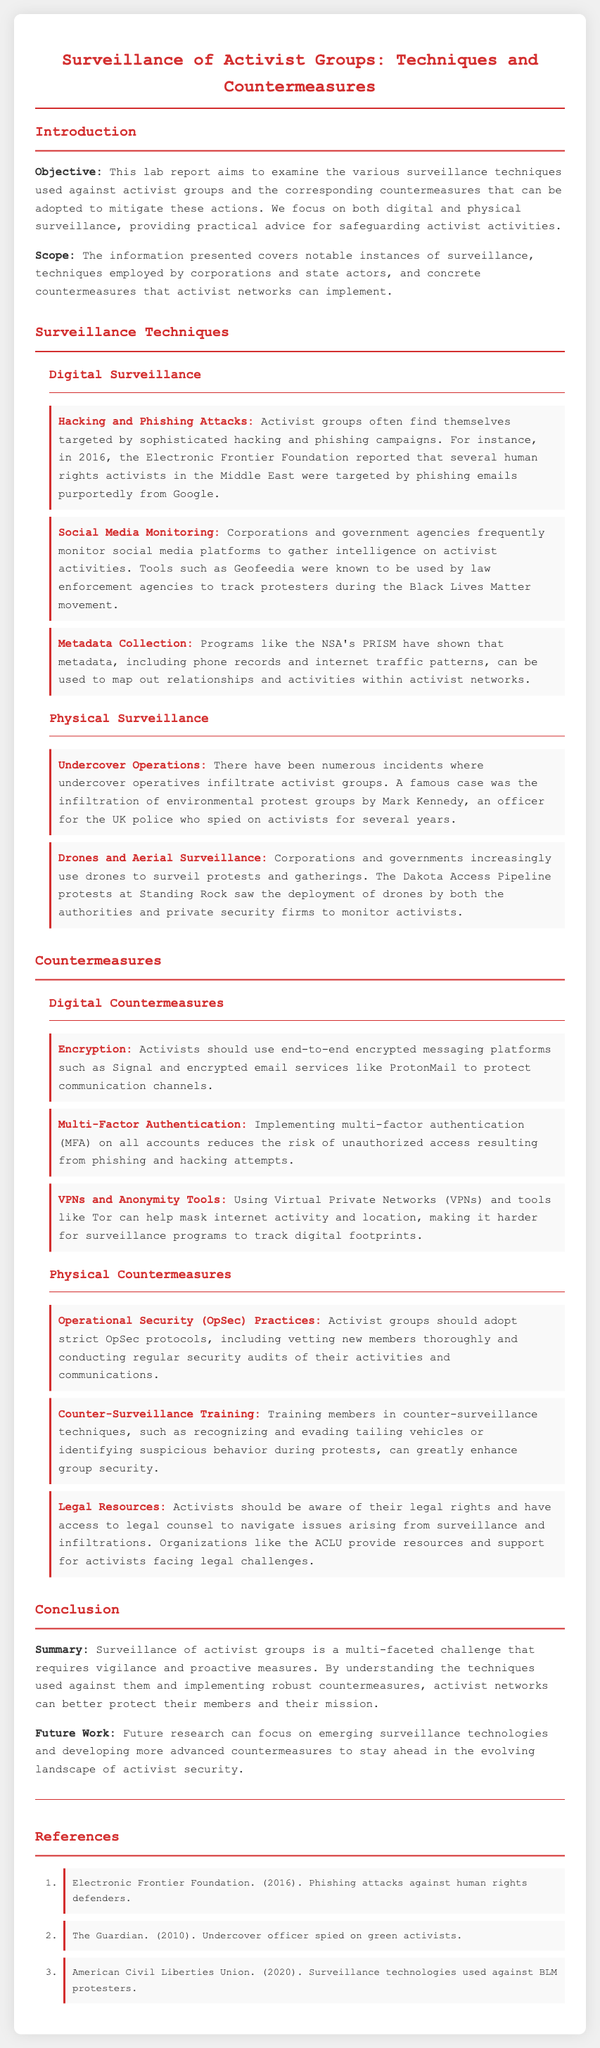what is the objective of the lab report? The objective aims to examine the various surveillance techniques used against activist groups and the corresponding countermeasures that can be adopted to mitigate these actions.
Answer: to examine surveillance techniques and countermeasures who reported phishing attacks against human rights defenders? The Electronic Frontier Foundation reported phishing attacks against human rights defenders.
Answer: Electronic Frontier Foundation what technique uses tools like Geofeedia? The technique that uses tools like Geofeedia is social media monitoring.
Answer: social media monitoring which physical surveillance method involved an undercover operative? The physical surveillance method involving an undercover operative is undercover operations.
Answer: undercover operations name one digital countermeasure suggested for activists. One digital countermeasure suggested for activists is encryption.
Answer: encryption what does OpSec stand for in the context of countermeasures? OpSec stands for Operational Security in the context of countermeasures.
Answer: Operational Security how many references are listed in the document? The document lists three references.
Answer: three what type of report is this document? This document is a lab report.
Answer: lab report what is the recommended resource for legal assistance? The recommended resource for legal assistance is the ACLU.
Answer: ACLU 